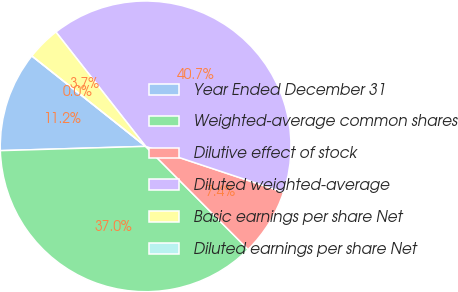Convert chart to OTSL. <chart><loc_0><loc_0><loc_500><loc_500><pie_chart><fcel>Year Ended December 31<fcel>Weighted-average common shares<fcel>Dilutive effect of stock<fcel>Diluted weighted-average<fcel>Basic earnings per share Net<fcel>Diluted earnings per share Net<nl><fcel>11.16%<fcel>36.98%<fcel>7.44%<fcel>40.7%<fcel>3.72%<fcel>0.0%<nl></chart> 